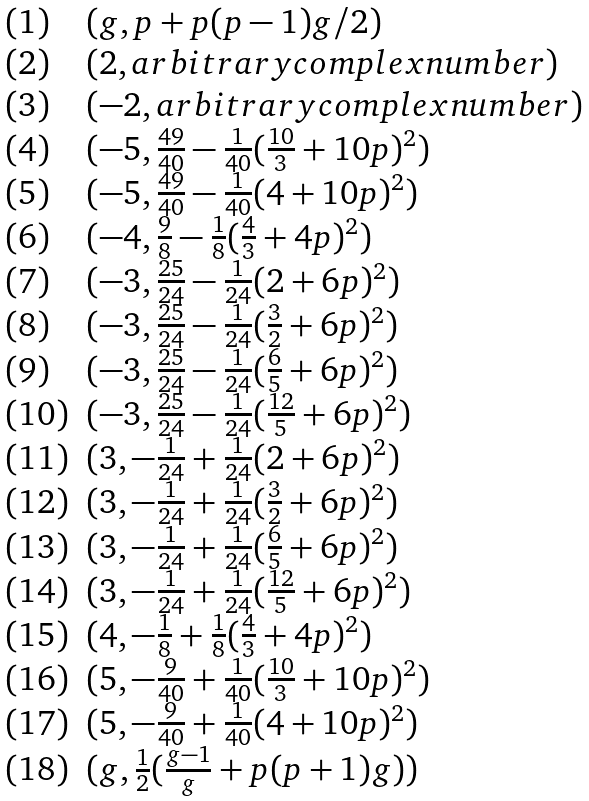<formula> <loc_0><loc_0><loc_500><loc_500>\begin{array} { l l } ( 1 ) & ( g , p + p ( p - 1 ) g / 2 ) \\ ( 2 ) & ( 2 , a r b i t r a r y c o m p l e x n u m b e r ) \\ ( 3 ) & ( - 2 , a r b i t r a r y c o m p l e x n u m b e r ) \\ ( 4 ) & ( - 5 , \frac { 4 9 } { 4 0 } - \frac { 1 } { 4 0 } ( \frac { 1 0 } { 3 } + 1 0 p ) ^ { 2 } ) \\ ( 5 ) & ( - 5 , \frac { 4 9 } { 4 0 } - \frac { 1 } { 4 0 } ( 4 + 1 0 p ) ^ { 2 } ) \\ ( 6 ) & ( - 4 , \frac { 9 } { 8 } - \frac { 1 } { 8 } ( \frac { 4 } { 3 } + 4 p ) ^ { 2 } ) \\ ( 7 ) & ( - 3 , \frac { 2 5 } { 2 4 } - \frac { 1 } { 2 4 } ( 2 + 6 p ) ^ { 2 } ) \\ ( 8 ) & ( - 3 , \frac { 2 5 } { 2 4 } - \frac { 1 } { 2 4 } ( \frac { 3 } { 2 } + 6 p ) ^ { 2 } ) \\ ( 9 ) & ( - 3 , \frac { 2 5 } { 2 4 } - \frac { 1 } { 2 4 } ( \frac { 6 } { 5 } + 6 p ) ^ { 2 } ) \\ ( 1 0 ) & ( - 3 , \frac { 2 5 } { 2 4 } - \frac { 1 } { 2 4 } ( \frac { 1 2 } { 5 } + 6 p ) ^ { 2 } ) \\ ( 1 1 ) & ( 3 , - \frac { 1 } { 2 4 } + \frac { 1 } { 2 4 } ( 2 + 6 p ) ^ { 2 } ) \\ ( 1 2 ) & ( 3 , - \frac { 1 } { 2 4 } + \frac { 1 } { 2 4 } ( \frac { 3 } { 2 } + 6 p ) ^ { 2 } ) \\ ( 1 3 ) & ( 3 , - \frac { 1 } { 2 4 } + \frac { 1 } { 2 4 } ( \frac { 6 } { 5 } + 6 p ) ^ { 2 } ) \\ ( 1 4 ) & ( 3 , - \frac { 1 } { 2 4 } + \frac { 1 } { 2 4 } ( \frac { 1 2 } { 5 } + 6 p ) ^ { 2 } ) \\ ( 1 5 ) & ( 4 , - \frac { 1 } { 8 } + \frac { 1 } { 8 } ( \frac { 4 } { 3 } + 4 p ) ^ { 2 } ) \\ ( 1 6 ) & ( 5 , - \frac { 9 } { 4 0 } + \frac { 1 } { 4 0 } ( \frac { 1 0 } { 3 } + 1 0 p ) ^ { 2 } ) \\ ( 1 7 ) & ( 5 , - \frac { 9 } { 4 0 } + \frac { 1 } { 4 0 } ( 4 + 1 0 p ) ^ { 2 } ) \\ ( 1 8 ) & ( g , \frac { 1 } { 2 } ( \frac { g - 1 } { g } + p ( p + 1 ) g ) ) \\ \end{array}</formula> 